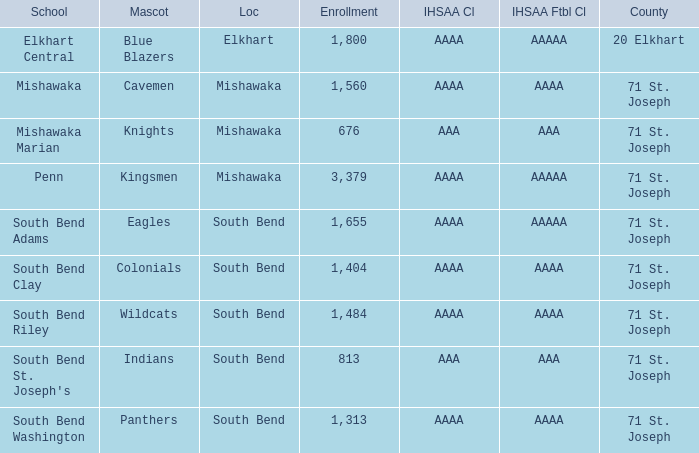In which ihsaa football class does elkhart county, with the number 20, belong? AAAAA. 